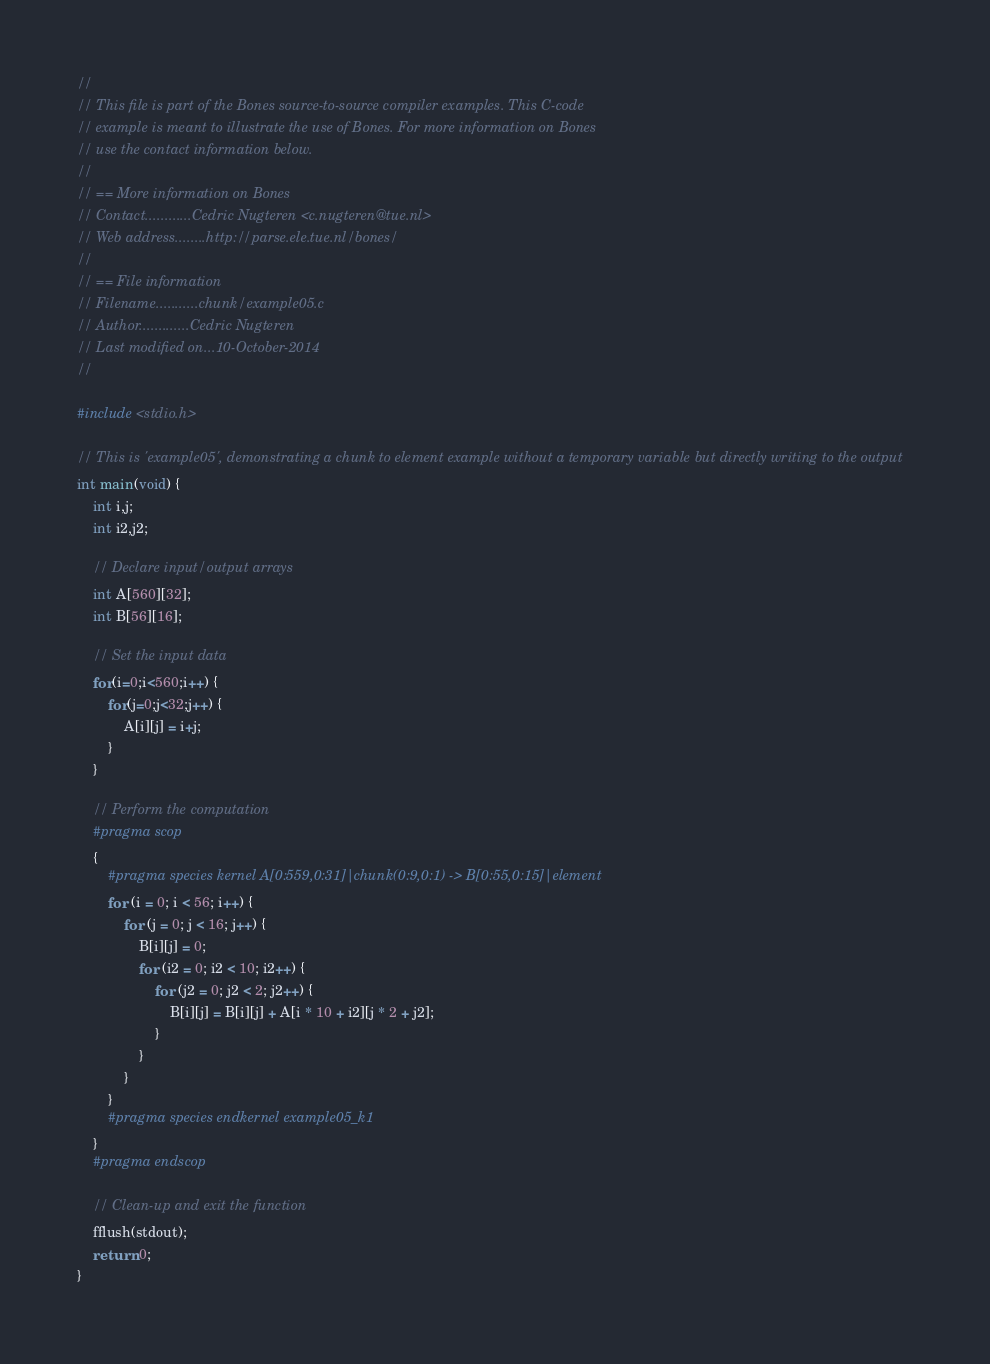<code> <loc_0><loc_0><loc_500><loc_500><_C_>//
// This file is part of the Bones source-to-source compiler examples. This C-code
// example is meant to illustrate the use of Bones. For more information on Bones
// use the contact information below.
//
// == More information on Bones
// Contact............Cedric Nugteren <c.nugteren@tue.nl>
// Web address........http://parse.ele.tue.nl/bones/
//
// == File information
// Filename...........chunk/example05.c
// Author.............Cedric Nugteren
// Last modified on...10-October-2014
//

#include <stdio.h>

// This is 'example05', demonstrating a chunk to element example without a temporary variable but directly writing to the output
int main(void) {
	int i,j;
	int i2,j2;
	
	// Declare input/output arrays
	int A[560][32];
	int B[56][16];
	
	// Set the input data
	for(i=0;i<560;i++) {
		for(j=0;j<32;j++) {
			A[i][j] = i+j;
		}
	}
	
	// Perform the computation
	#pragma scop
	{
		#pragma species kernel A[0:559,0:31]|chunk(0:9,0:1) -> B[0:55,0:15]|element
		for (i = 0; i < 56; i++) {
			for (j = 0; j < 16; j++) {
				B[i][j] = 0;
				for (i2 = 0; i2 < 10; i2++) {
					for (j2 = 0; j2 < 2; j2++) {
						B[i][j] = B[i][j] + A[i * 10 + i2][j * 2 + j2];
					}
				}
			}
		}
		#pragma species endkernel example05_k1
	}
	#pragma endscop
	
	// Clean-up and exit the function
	fflush(stdout);
	return 0;
}

</code> 